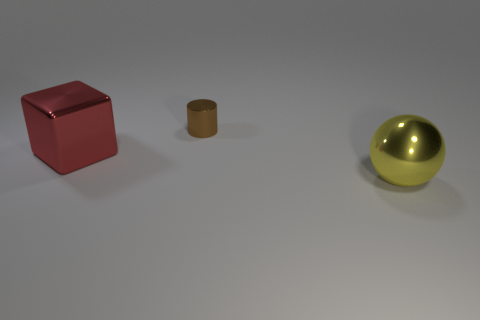What is the size of the metallic thing behind the object to the left of the small brown metallic object? The metallic object behind the red cube and to the left of the small brown cylinder appears to be a gold-colored sphere. Compared to the small brown cylinder, the sphere is considerably larger with a reflective surface that suggests it is made of a polished material, possibly metal. 